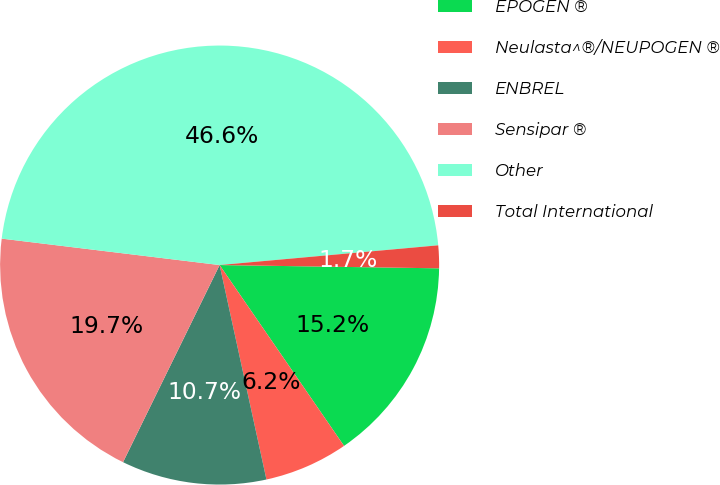Convert chart. <chart><loc_0><loc_0><loc_500><loc_500><pie_chart><fcel>EPOGEN ®<fcel>Neulasta^®/NEUPOGEN ®<fcel>ENBREL<fcel>Sensipar ®<fcel>Other<fcel>Total International<nl><fcel>15.17%<fcel>6.17%<fcel>10.67%<fcel>19.67%<fcel>46.64%<fcel>1.67%<nl></chart> 